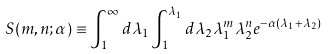<formula> <loc_0><loc_0><loc_500><loc_500>S ( m , n ; \alpha ) \equiv \int ^ { \infty } _ { 1 } d \lambda _ { 1 } \int ^ { \lambda _ { 1 } } _ { 1 } d \lambda _ { 2 } \lambda _ { 1 } ^ { m } \lambda _ { 2 } ^ { n } e ^ { - \alpha ( \lambda _ { 1 } + \lambda _ { 2 } ) }</formula> 